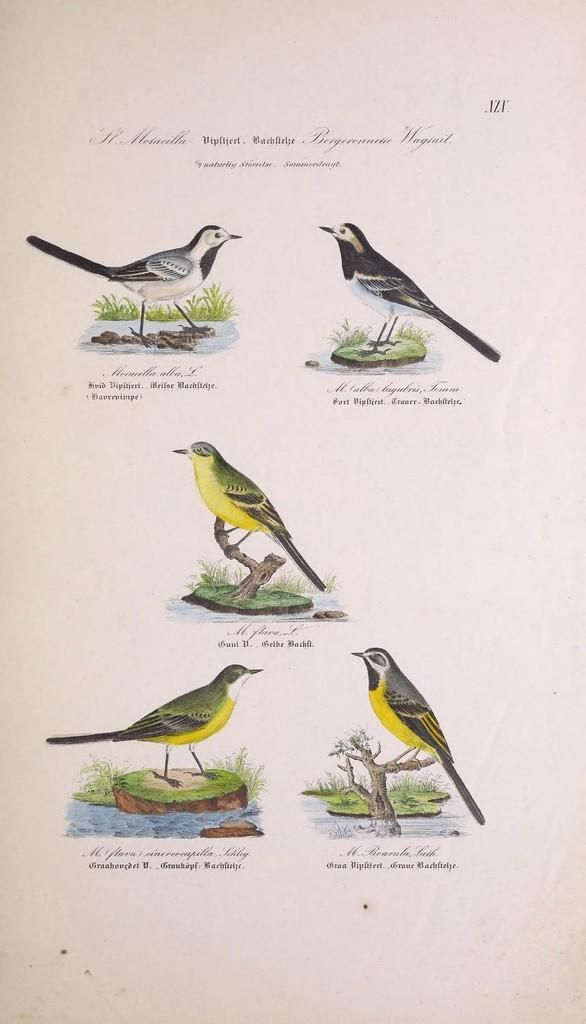How many bird pictures are in the image? There are five pictures of birds in the image. What else can be seen in the image besides the bird pictures? There is text present in the image. How many babies are holding the arm of the bird in the image? There are no babies or arms present in the image; it only contains pictures of birds and text. 